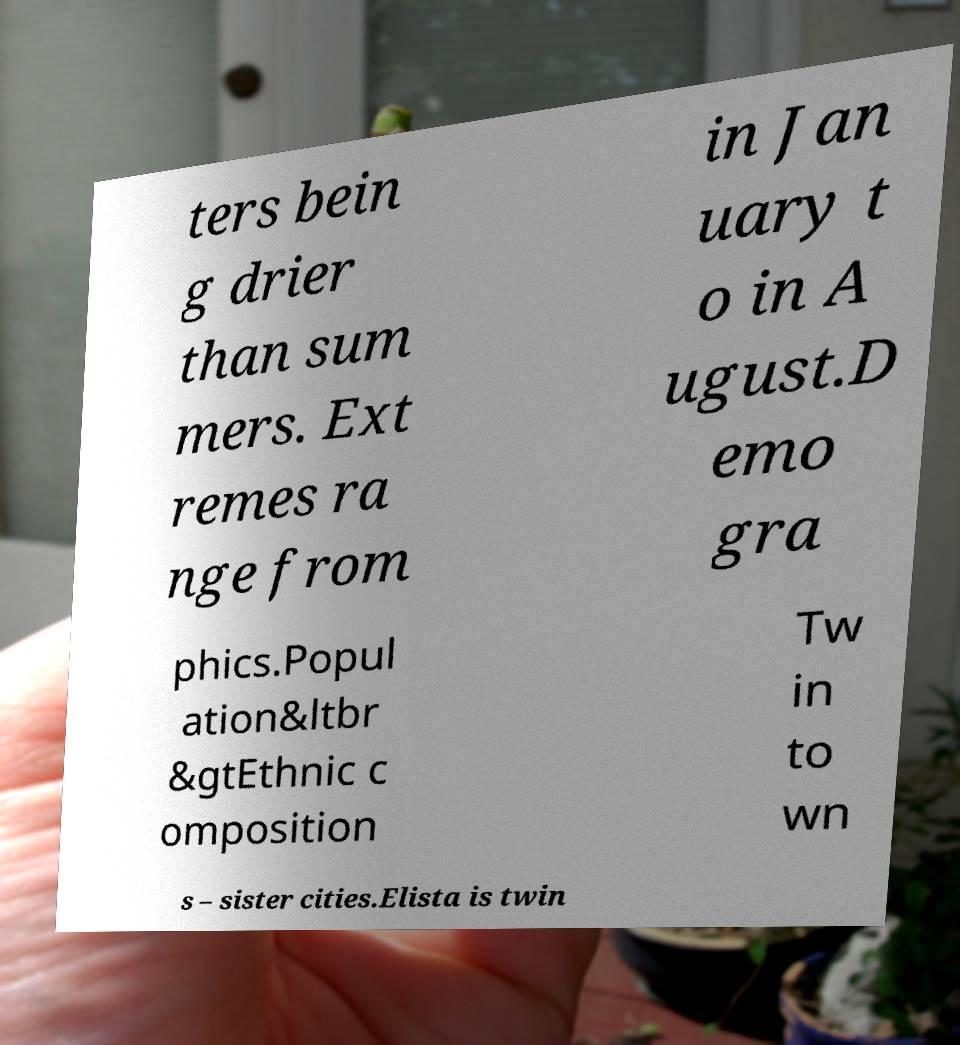There's text embedded in this image that I need extracted. Can you transcribe it verbatim? ters bein g drier than sum mers. Ext remes ra nge from in Jan uary t o in A ugust.D emo gra phics.Popul ation&ltbr &gtEthnic c omposition Tw in to wn s – sister cities.Elista is twin 